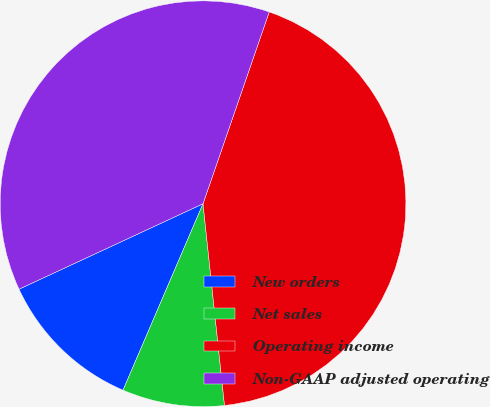<chart> <loc_0><loc_0><loc_500><loc_500><pie_chart><fcel>New orders<fcel>Net sales<fcel>Operating income<fcel>Non-GAAP adjusted operating<nl><fcel>11.63%<fcel>8.14%<fcel>43.02%<fcel>37.21%<nl></chart> 